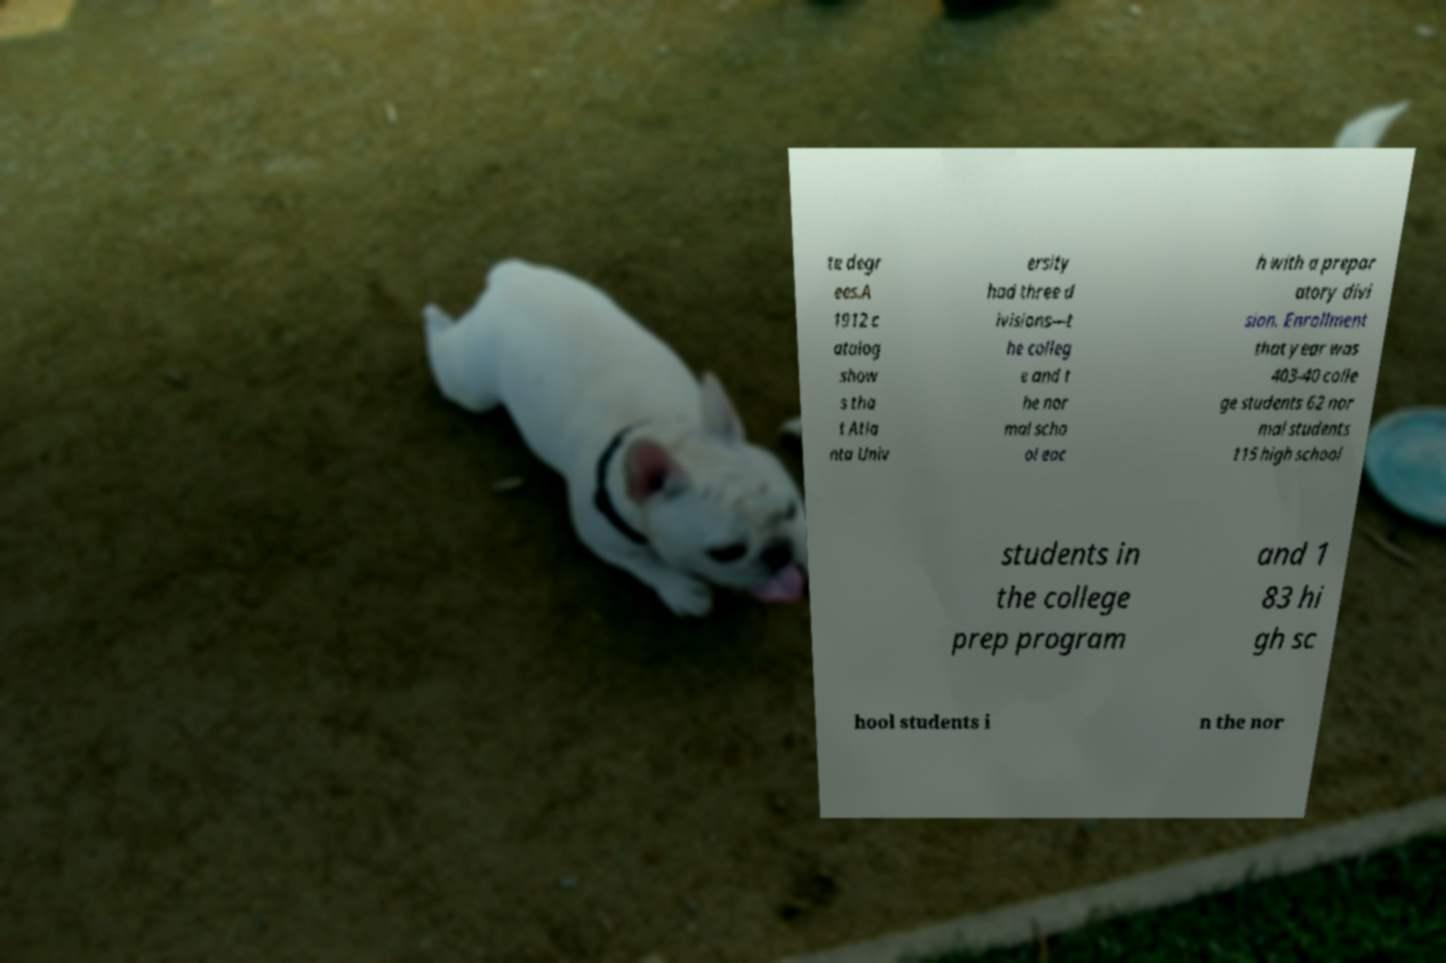What messages or text are displayed in this image? I need them in a readable, typed format. te degr ees.A 1912 c atalog show s tha t Atla nta Univ ersity had three d ivisions—t he colleg e and t he nor mal scho ol eac h with a prepar atory divi sion. Enrollment that year was 403-40 colle ge students 62 nor mal students 115 high school students in the college prep program and 1 83 hi gh sc hool students i n the nor 